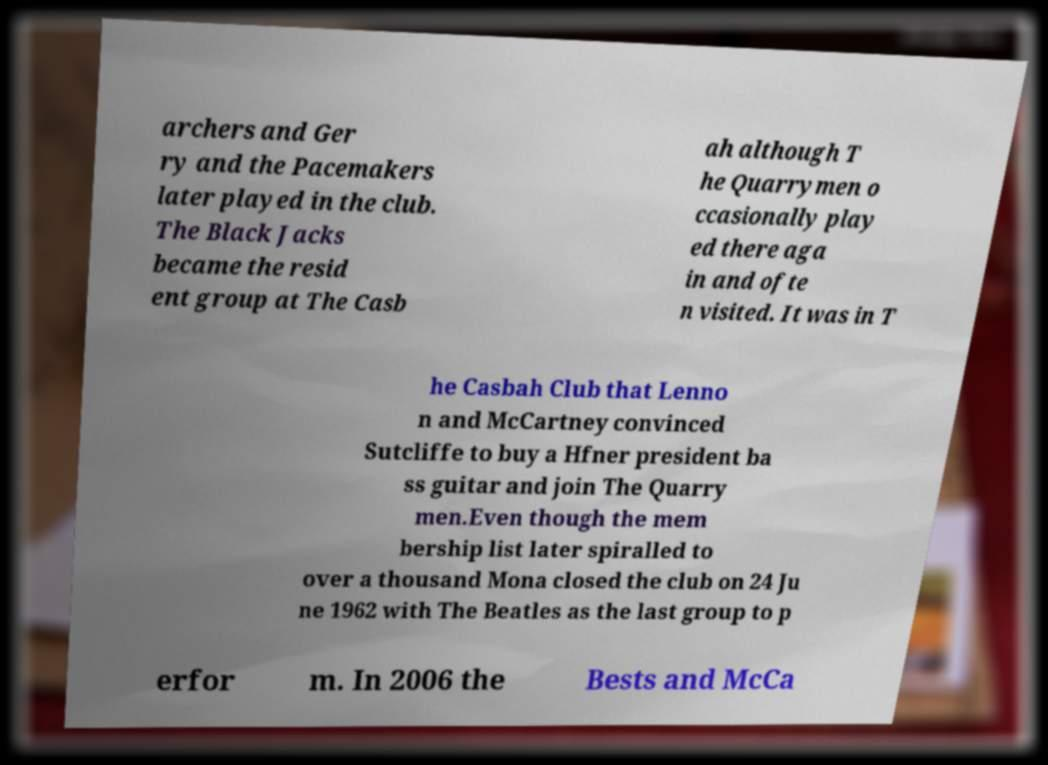Please read and relay the text visible in this image. What does it say? archers and Ger ry and the Pacemakers later played in the club. The Black Jacks became the resid ent group at The Casb ah although T he Quarrymen o ccasionally play ed there aga in and ofte n visited. It was in T he Casbah Club that Lenno n and McCartney convinced Sutcliffe to buy a Hfner president ba ss guitar and join The Quarry men.Even though the mem bership list later spiralled to over a thousand Mona closed the club on 24 Ju ne 1962 with The Beatles as the last group to p erfor m. In 2006 the Bests and McCa 